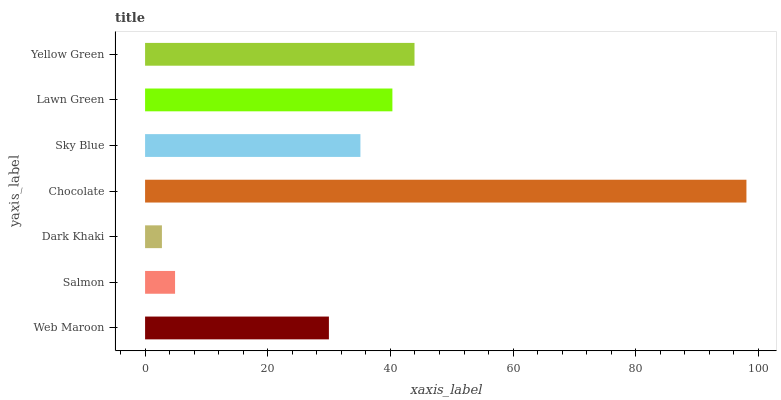Is Dark Khaki the minimum?
Answer yes or no. Yes. Is Chocolate the maximum?
Answer yes or no. Yes. Is Salmon the minimum?
Answer yes or no. No. Is Salmon the maximum?
Answer yes or no. No. Is Web Maroon greater than Salmon?
Answer yes or no. Yes. Is Salmon less than Web Maroon?
Answer yes or no. Yes. Is Salmon greater than Web Maroon?
Answer yes or no. No. Is Web Maroon less than Salmon?
Answer yes or no. No. Is Sky Blue the high median?
Answer yes or no. Yes. Is Sky Blue the low median?
Answer yes or no. Yes. Is Salmon the high median?
Answer yes or no. No. Is Chocolate the low median?
Answer yes or no. No. 